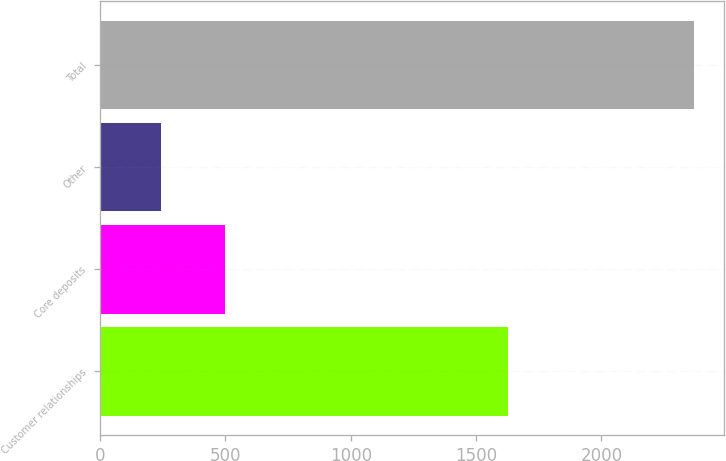<chart> <loc_0><loc_0><loc_500><loc_500><bar_chart><fcel>Customer relationships<fcel>Core deposits<fcel>Other<fcel>Total<nl><fcel>1628<fcel>500<fcel>243<fcel>2371<nl></chart> 